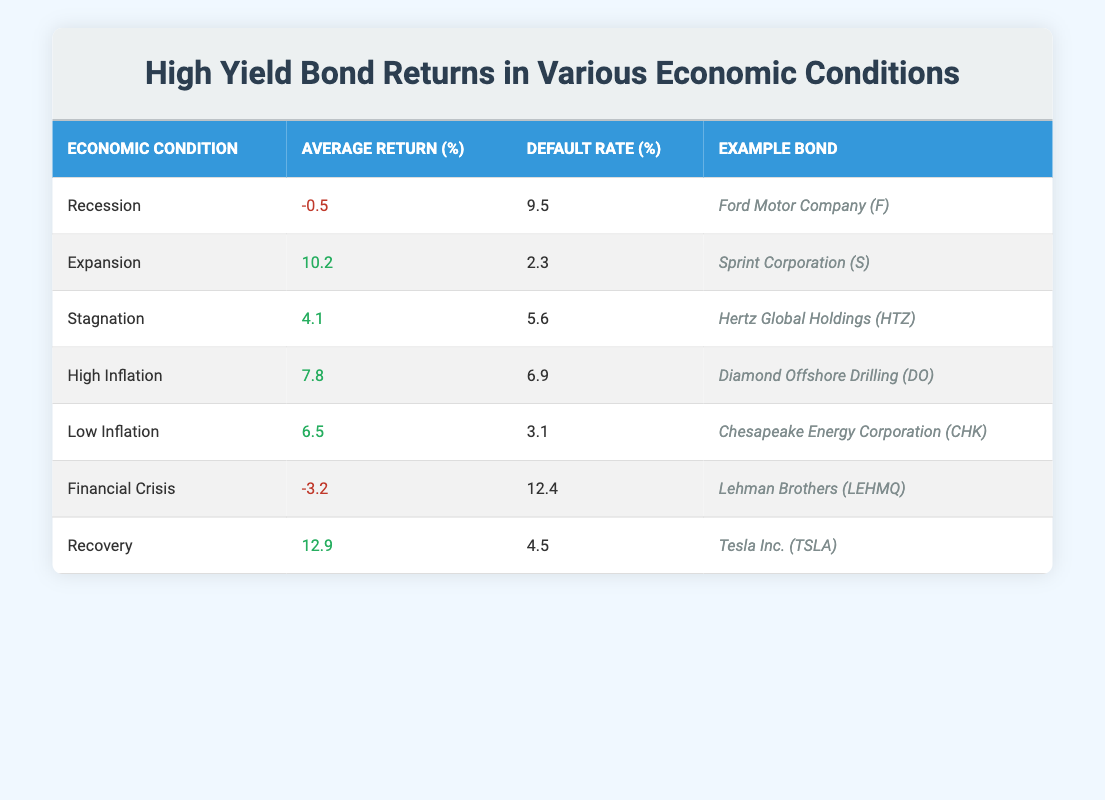What is the average return of high yield bonds during a recession? In the table, the average return during a recession is listed under the "Average Return (%)" column corresponding to the "Recession" row, which shows -0.5.
Answer: -0.5 Which economic condition has the highest average return for high yield bonds? By examining the "Average Return (%)" column, the value 12.9 under the "Recovery" row is the highest.
Answer: Recovery What is the example bond for high yield bonds during an expansion period? Referring to the "Example Bond" column in the "Expansion" row, it is listed as Sprint Corporation (S).
Answer: Sprint Corporation (S) Is the default rate higher during a financial crisis compared to a recession? Comparing the "Default Rate (%)" values, the financial crisis shows 12.4 while the recession shows 9.5. Since 12.4 is greater than 9.5, the answer is yes.
Answer: Yes What is the difference in average returns between recovery and recession? The average return during recovery is 12.9 and during recession is -0.5. To find the difference, subtract -0.5 from 12.9, which gives 12.9 + 0.5 = 13.4.
Answer: 13.4 What is the average default rate during low inflation and high inflation periods? From the table, the default rate under "Low Inflation" is 3.1 and under "High Inflation" is 6.9. To find the average, add them together (3.1 + 6.9 = 10) and divide by 2 (10 / 2 = 5).
Answer: 5 Are high yield bonds a riskier investment during a financial crisis compared to other economic conditions based on the default rates? The highest default rate is 12.4 during the financial crisis, which is greater than default rates in recession (9.5) and stagnation (5.6), indicating it is riskier.
Answer: Yes What economic condition has an average return above 5% along with a default rate under 5%? By checking the table, both "Low Inflation" (6.5% average return and 3.1% default rate) meets these criteria. No other conditions with returns above 5% have a default rate under 5%.
Answer: Low Inflation 